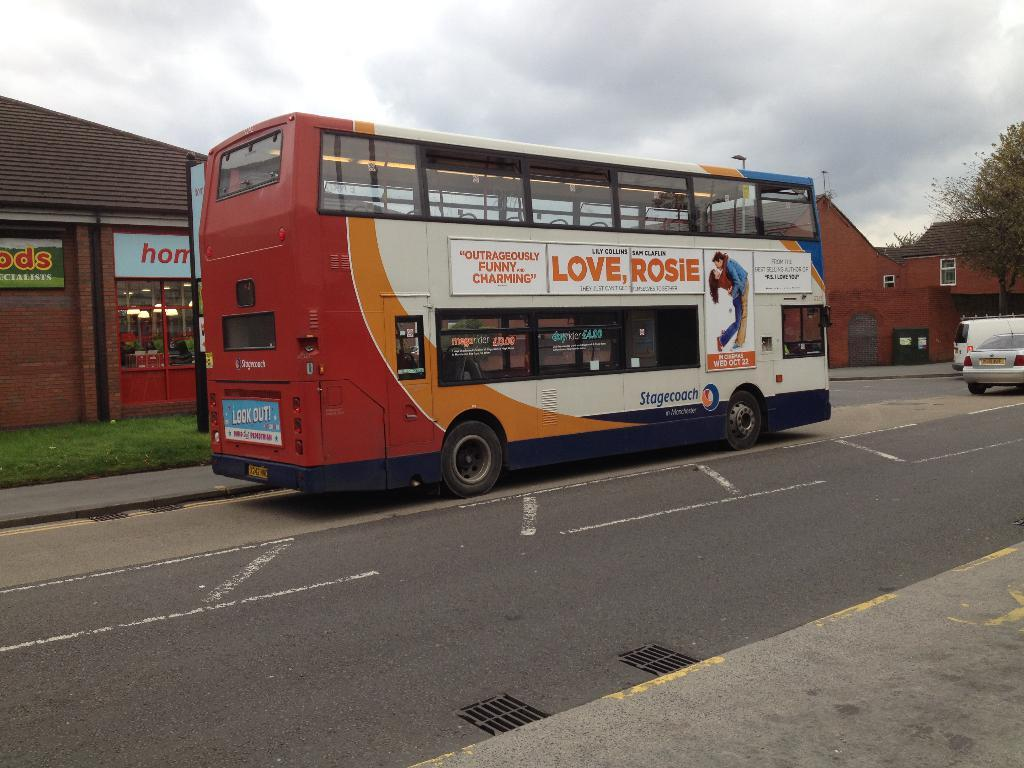<image>
Offer a succinct explanation of the picture presented. A two story bus with advertisement for Love Rosie, the movie. 